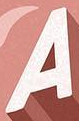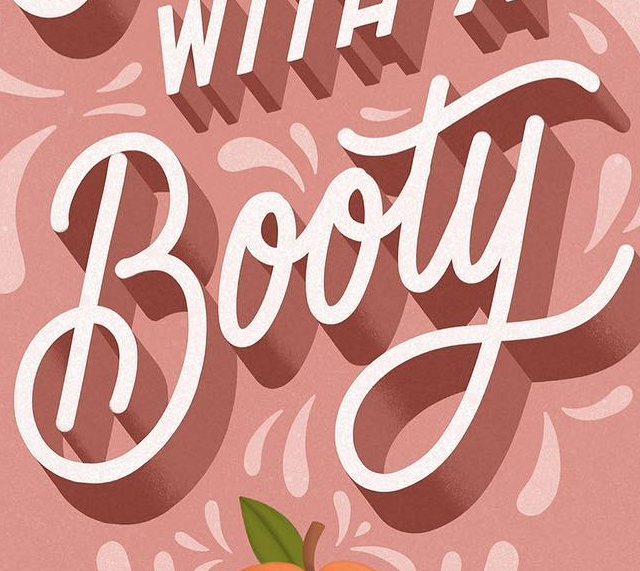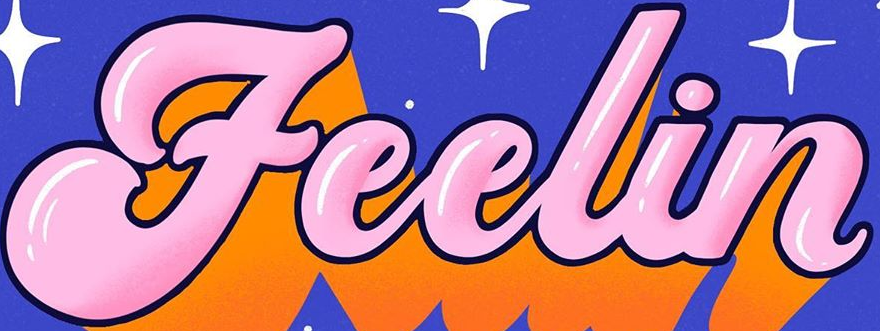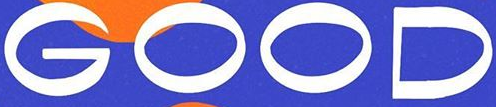Read the text content from these images in order, separated by a semicolon. A; Booty; Feelin; GOOD 